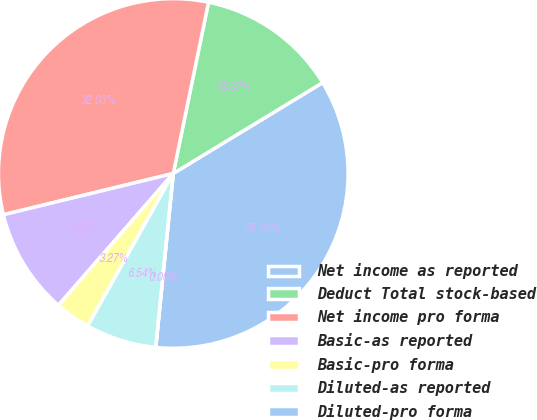Convert chart. <chart><loc_0><loc_0><loc_500><loc_500><pie_chart><fcel>Net income as reported<fcel>Deduct Total stock-based<fcel>Net income pro forma<fcel>Basic-as reported<fcel>Basic-pro forma<fcel>Diluted-as reported<fcel>Diluted-pro forma<nl><fcel>35.3%<fcel>13.07%<fcel>32.03%<fcel>9.8%<fcel>3.27%<fcel>6.54%<fcel>0.0%<nl></chart> 